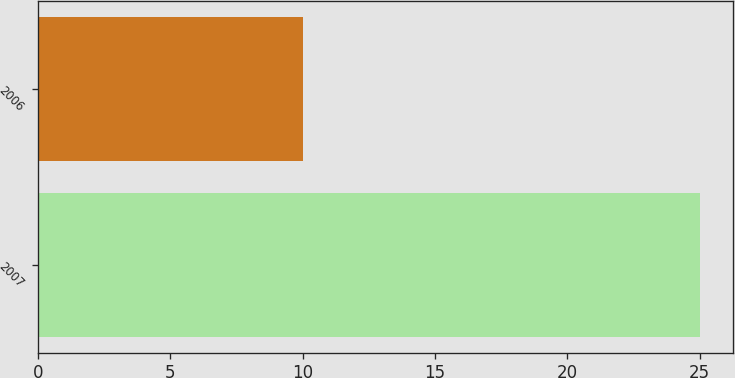Convert chart to OTSL. <chart><loc_0><loc_0><loc_500><loc_500><bar_chart><fcel>2007<fcel>2006<nl><fcel>25<fcel>10<nl></chart> 